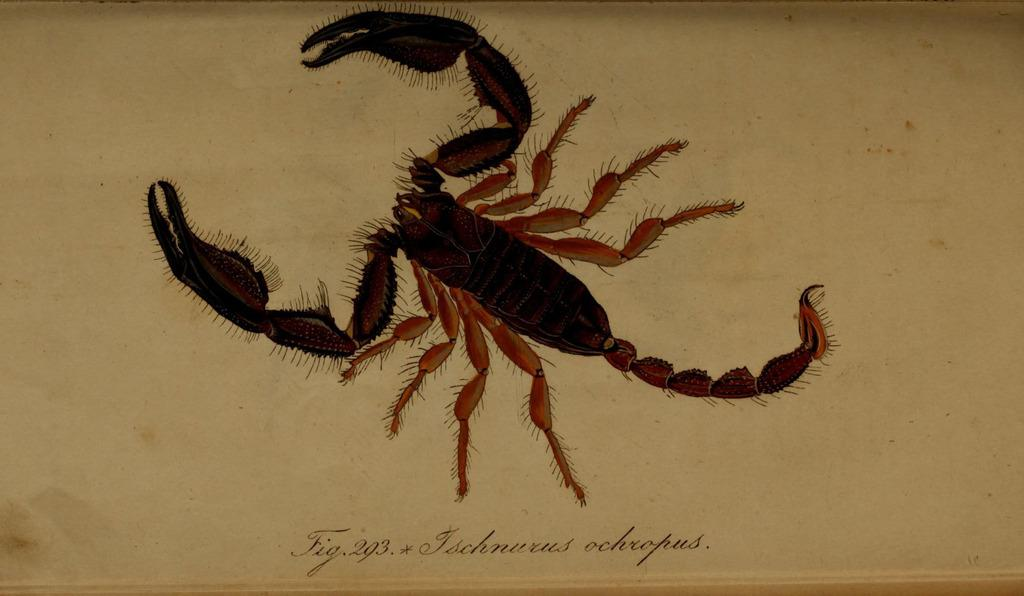What is the main subject of the picture? The main subject of the picture is a Scorpio. What are some of the features of the Scorpio? The Scorpio has hands, a tail, and eight legs. Is there any text or writing in the picture? Yes, there is something written on the bottom of the picture. What type of ball can be seen in the picture? There is no ball present in the picture; it features a Scorpio with hands, a tail, and eight legs. What kind of leather material is used to make the Scorpio's body? The Scorpio is not a real animal, and therefore it does not have a body made of leather. 